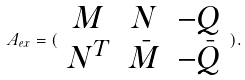<formula> <loc_0><loc_0><loc_500><loc_500>A _ { e x } = ( \begin{array} { c c c } M & N & - Q \\ N ^ { T } & \bar { M } & - \bar { Q } \end{array} ) .</formula> 